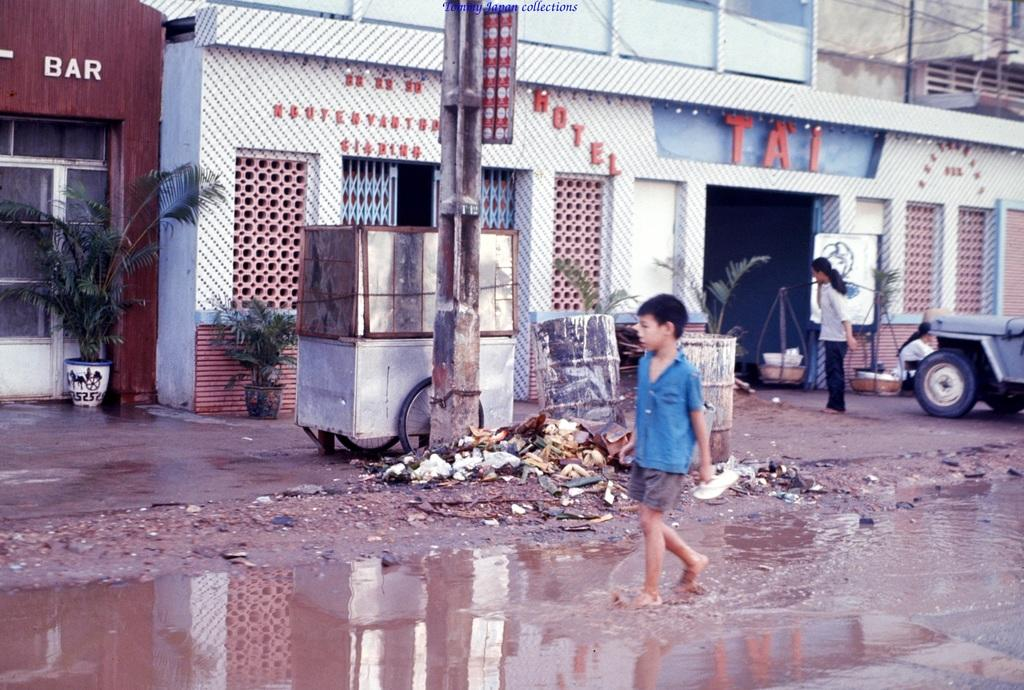What is the boy in the image doing? The boy is walking in the water. What can be seen in the background of the image? There are buildings, walls, plants, objects, vehicles, a grill, and pillars visible in the background. How many people are present in the image? There are two people in the image. What type of bit is the boy using to control the current in the image? There is no bit or current present in the image; it features a boy walking in the water. Can you describe the bedroom in the image? There is no bedroom present in the image. 